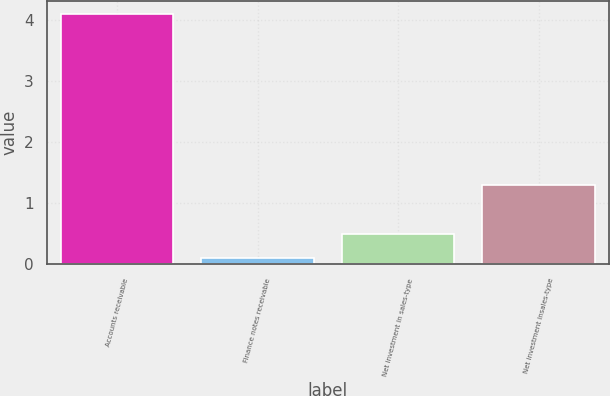Convert chart. <chart><loc_0><loc_0><loc_500><loc_500><bar_chart><fcel>Accounts receivable<fcel>Finance notes receivable<fcel>Net investment in sales-type<fcel>Net investment insales-type<nl><fcel>4.1<fcel>0.1<fcel>0.5<fcel>1.3<nl></chart> 